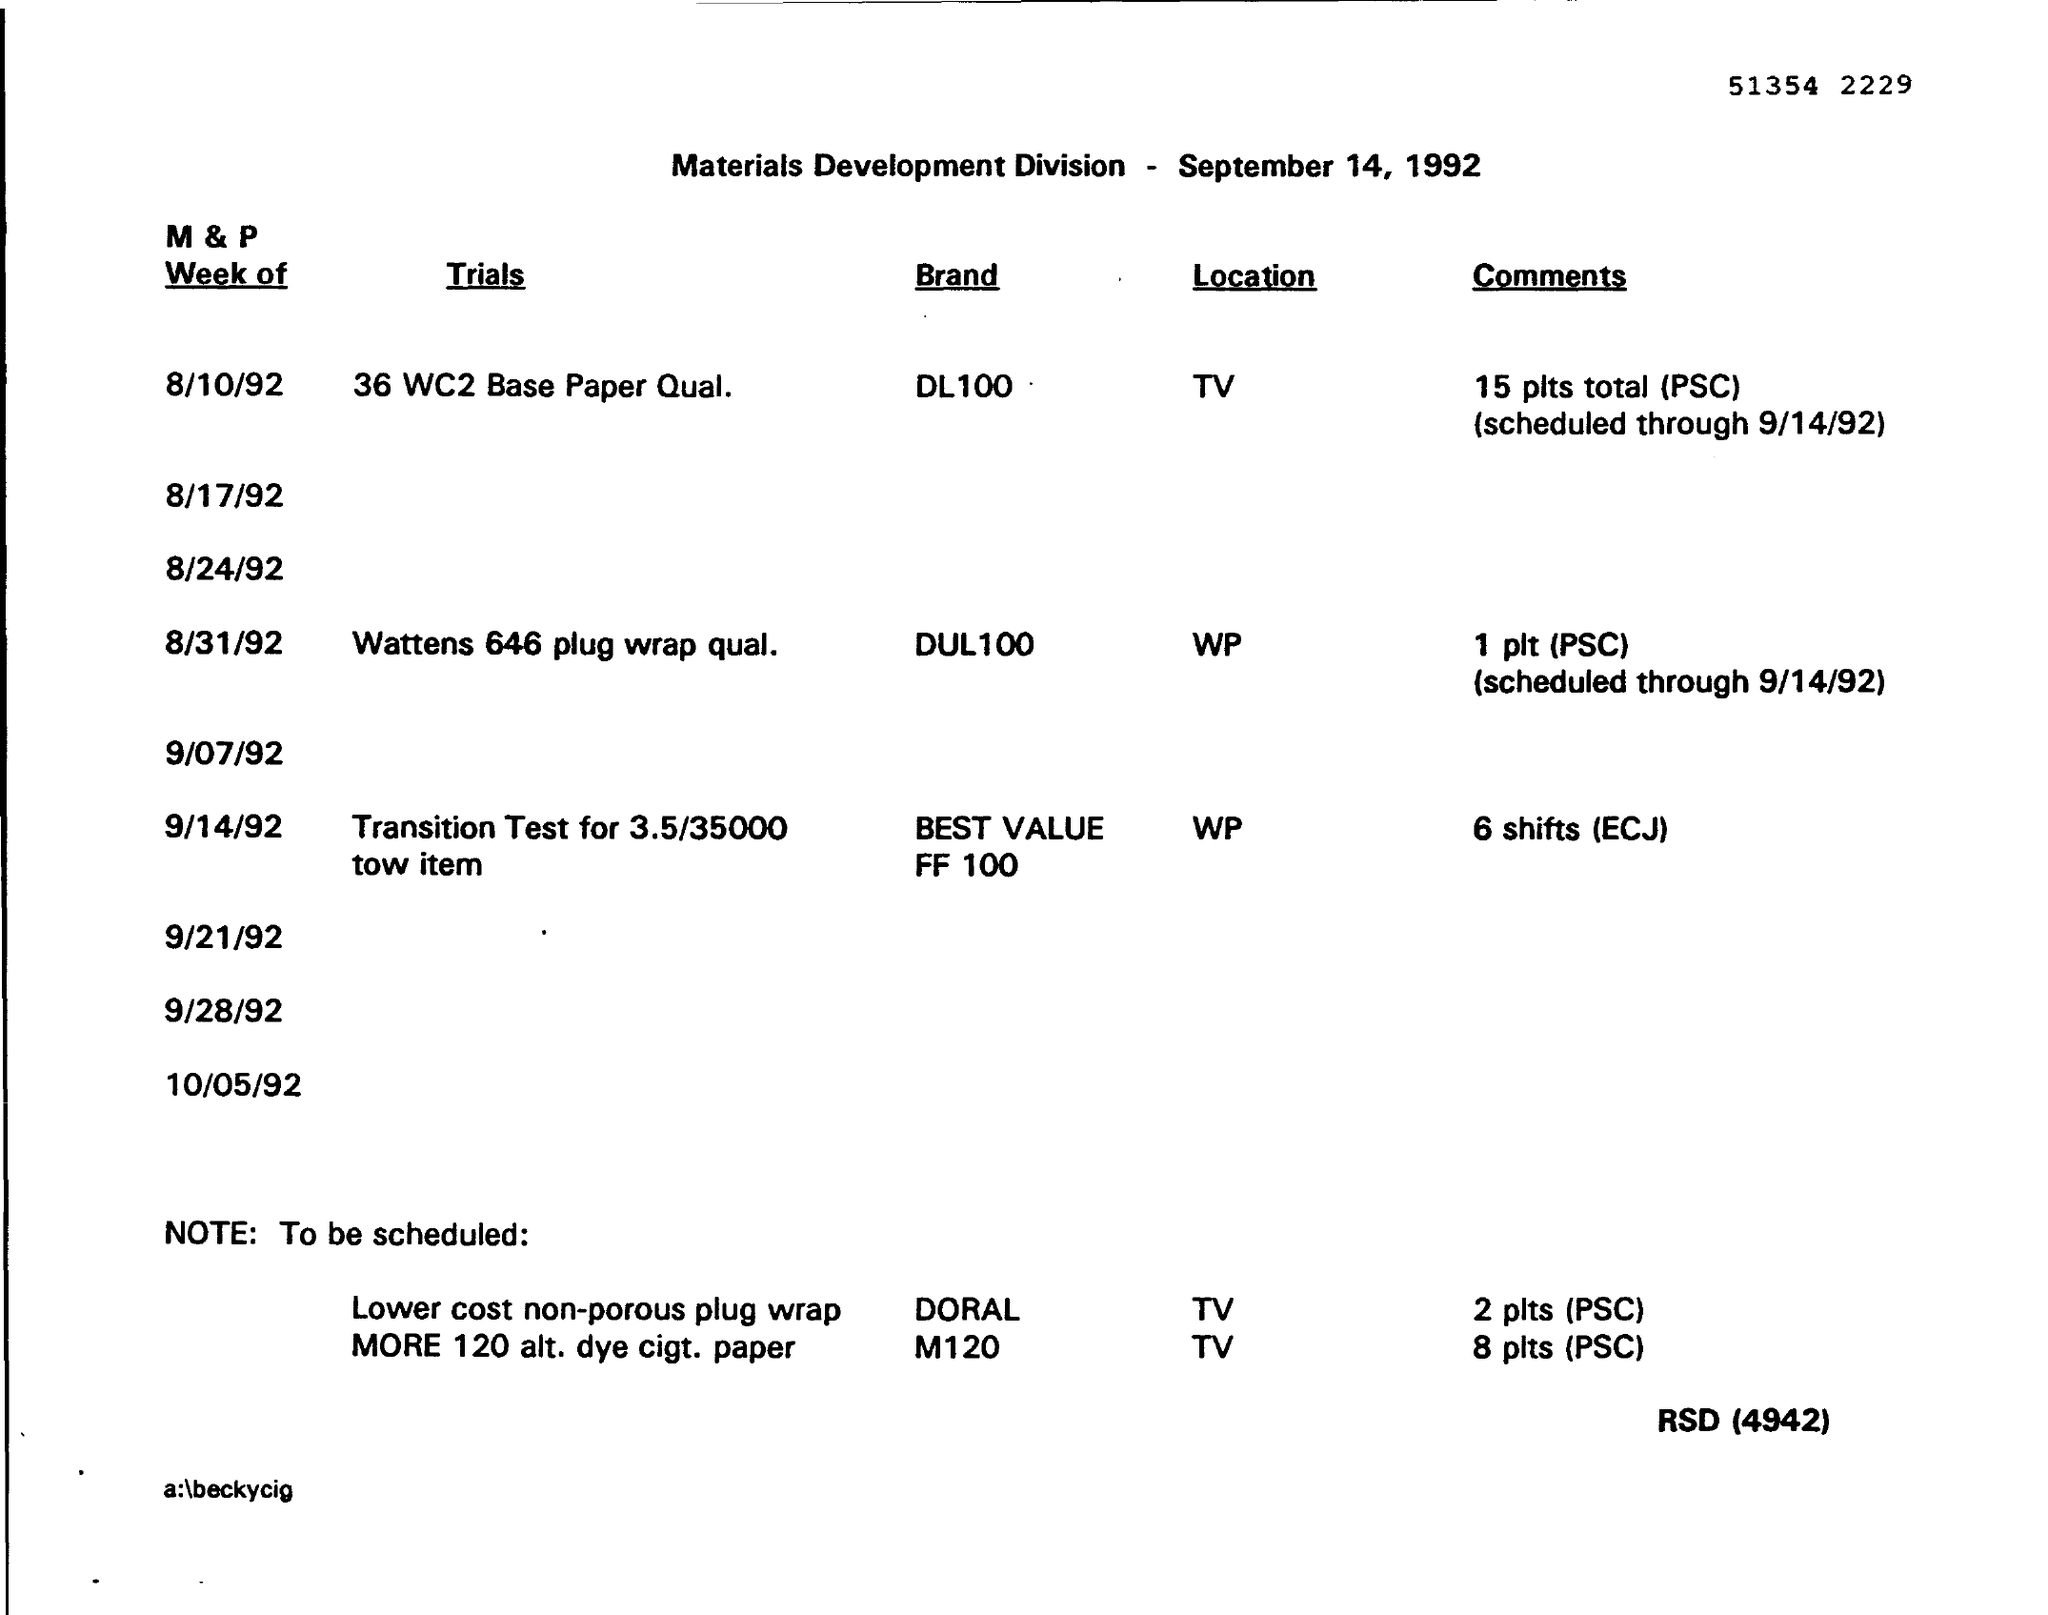What is the Trials's name on 8/31/92?
Make the answer very short. Wattens 646 plug wrap qual. What is the location of the Brand DUL 100?
Give a very brief answer. WP. What is the location of theTrial 36 WC2 Base Paper Qual?
Make the answer very short. TV. 